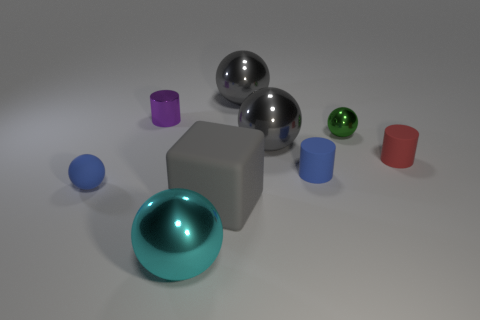There is a small blue rubber thing that is on the right side of the blue ball; are there any small purple cylinders to the right of it? no 